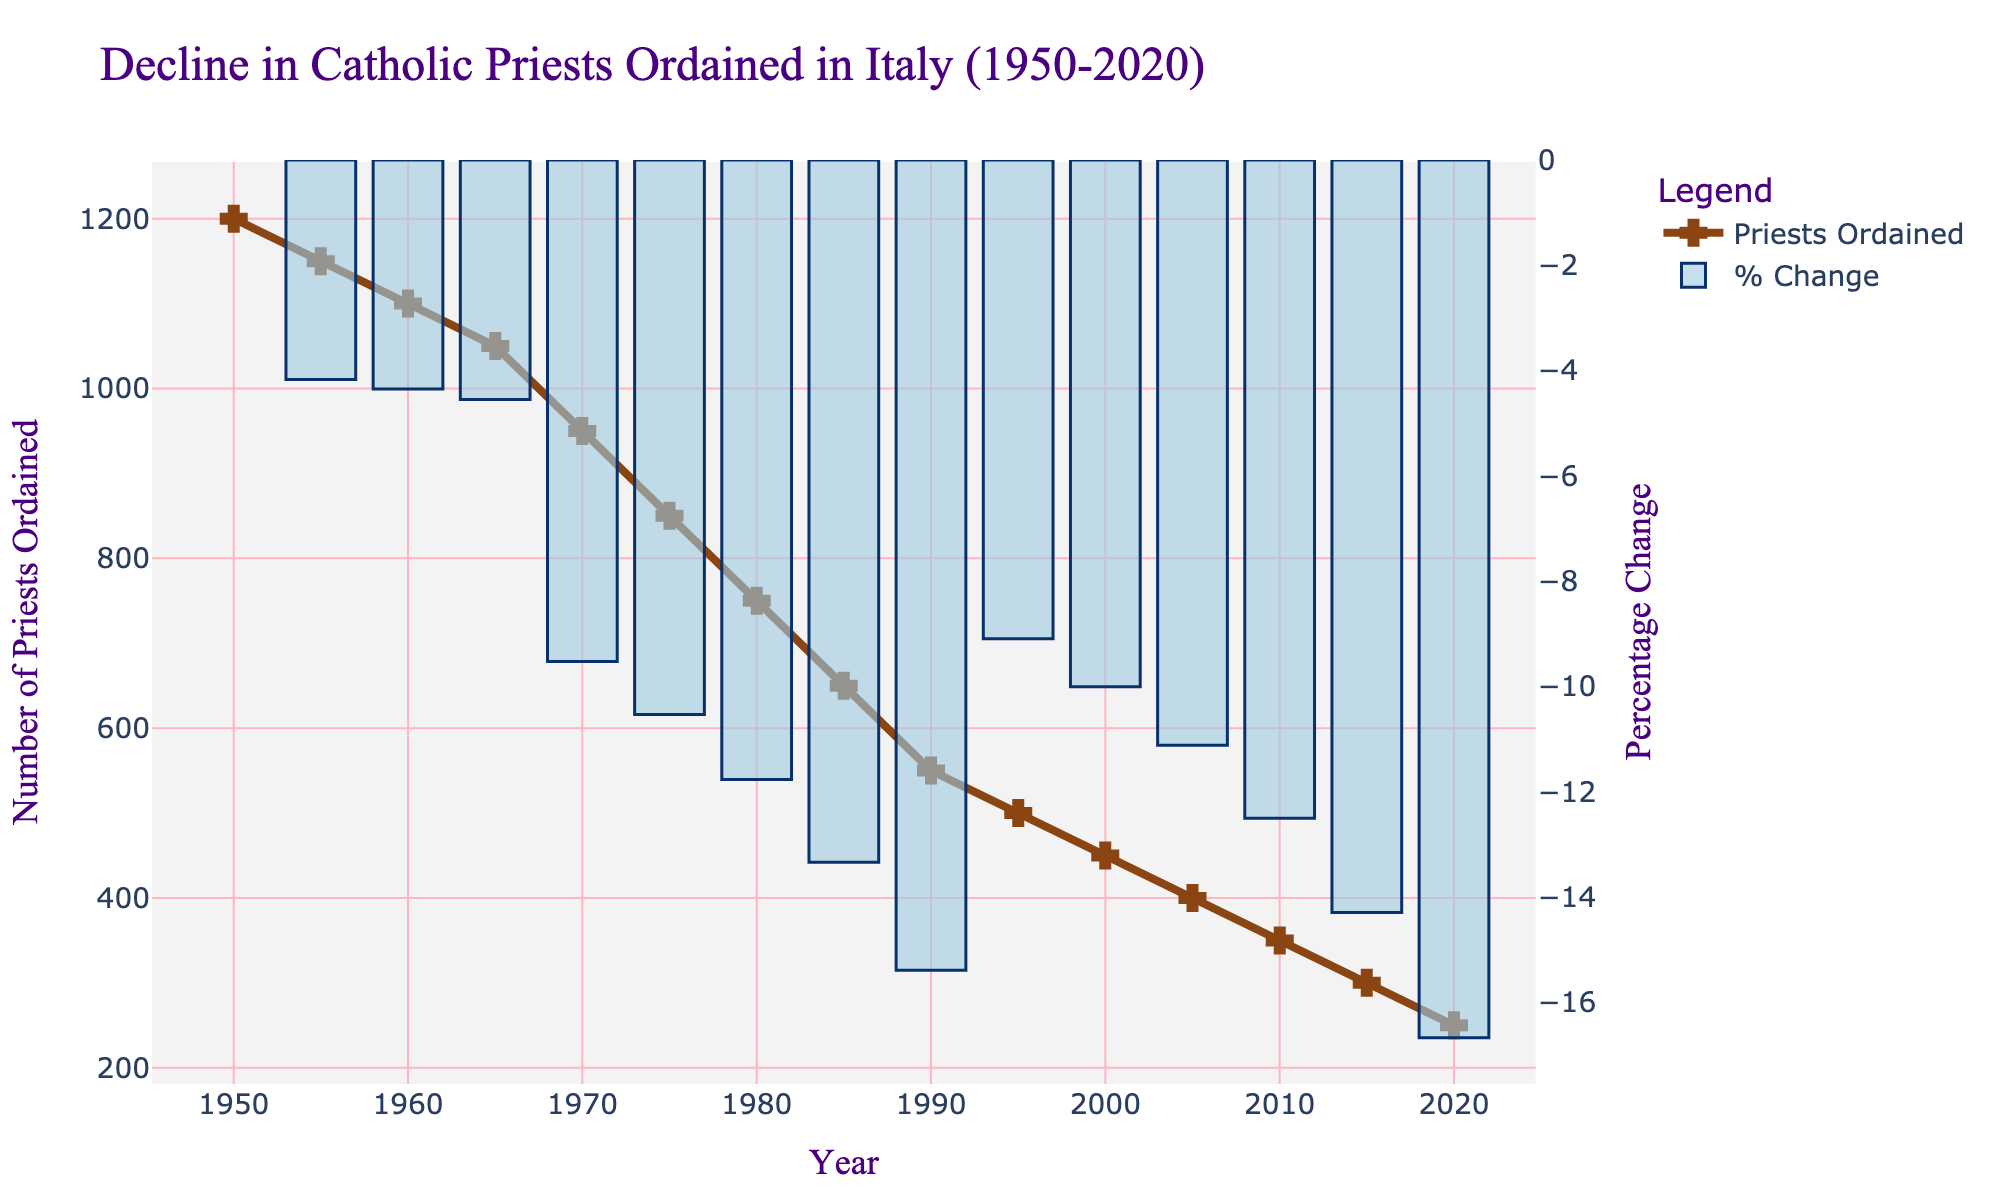what is the difference in the number of priests ordained between 1950 and 2020? To find the difference in the number of priests ordained between 1950 (1200 priests) and 2020 (250 priests), subtract the 2020 value from the 1950 value: 1200 - 250 = 950
Answer: 950 During which decade did the number of priests ordained show the greatest decline in the figure? To identify the decade with the greatest decline, examine the drops between each set of five years: the largest decline appears between 1965 (1050 priests) and 1975 (850 priests), a difference of 200 priests.
Answer: 1965-1975 How does the percentage change in the number of priests ordained in 2020 compare to that in 1955? The bar for 2020 is much higher, indicating a larger percentage decline compared to 1955, where the percentage change was closer to zero. This means 2020 saw a significant percentage drop compared to 1955.
Answer: 2020 showed a greater decline What is the average number of priests ordained annually in Italy between 1950 and 1970? Identify the values from 1950 to 1970: 1200, 1150, 1100, 1050, 950. Sum these values (1200 + 1150 + 1100 + 1050 + 950 = 5450) and divide by the number of years (5). 5450 / 5 = 1090
Answer: 1090 In what year did the number of priests ordained fall below 500 for the first time? Examine the data points and identify that the first year when the number of priests fell below 500 is 1995.
Answer: 1995 Which visual element illustrates the percentage change in priest ordinations? The bar chart element in the figure indicates the percentage change in priest ordinations.
Answer: bar chart What trend is observed in the number of priests ordained from 1950 to 2020? The line graph shows a consistent and steady decline in the number of priests ordained from 1950 (1200 priests) to 2020 (250 priests).
Answer: consistent decline Compare the visual lengths of lines or bars for the years 1980 and 2010. Which year had more priests ordained, and how can you tell? The line segment for 1980 is higher, indicating 750 priests ordained compared to the 2010 segment at 350 priests, showing that there were more priests ordained in 1980.
Answer: 1980 had more priests ordained In which year did the percentage change in the number of priests ordained become the most negative, and how can this be visually identified? The year with the greatest negative percentage change is visually identified by the tallest bar below zero; this occurs in the latter half of the 20th century, particularly near 1990.
Answer: around 1990 